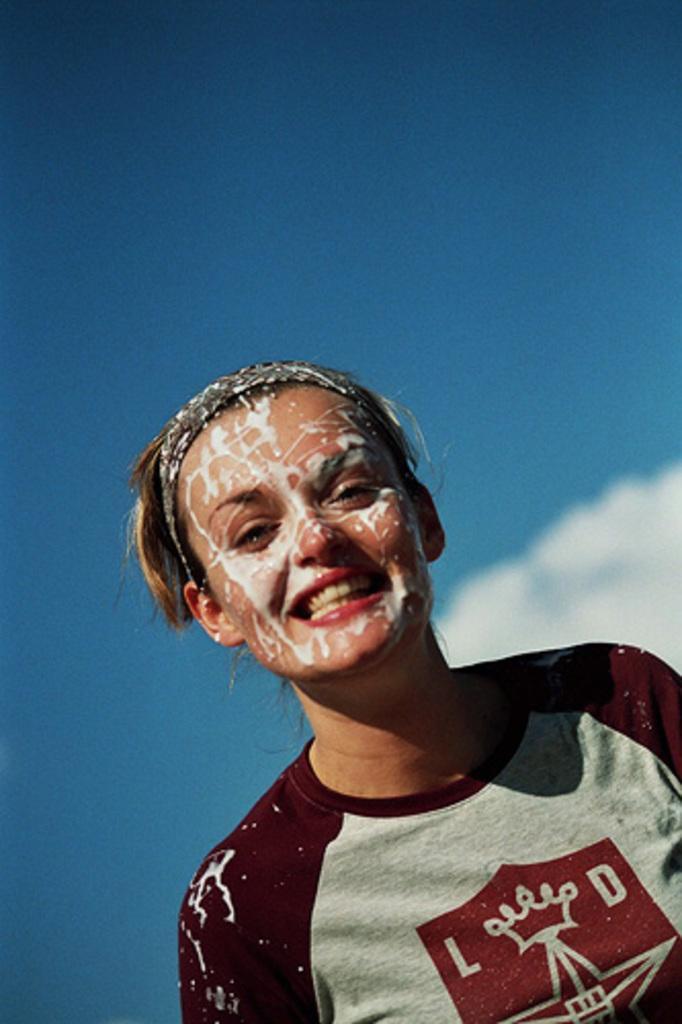Could you give a brief overview of what you see in this image? In this image I can see a woman in the front. I can see smile on her face and I can also see white colour thing on her face. I can also see she is wearing maroon and grey colour t shirt. In the background I can see the sky and a cloud. 